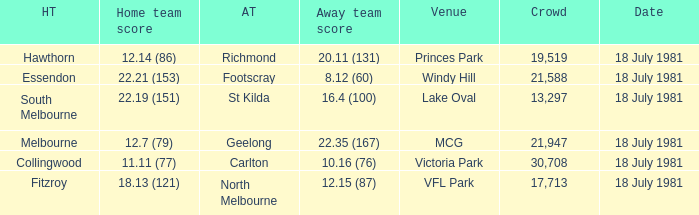What was the date of the essendon home match? 18 July 1981. 